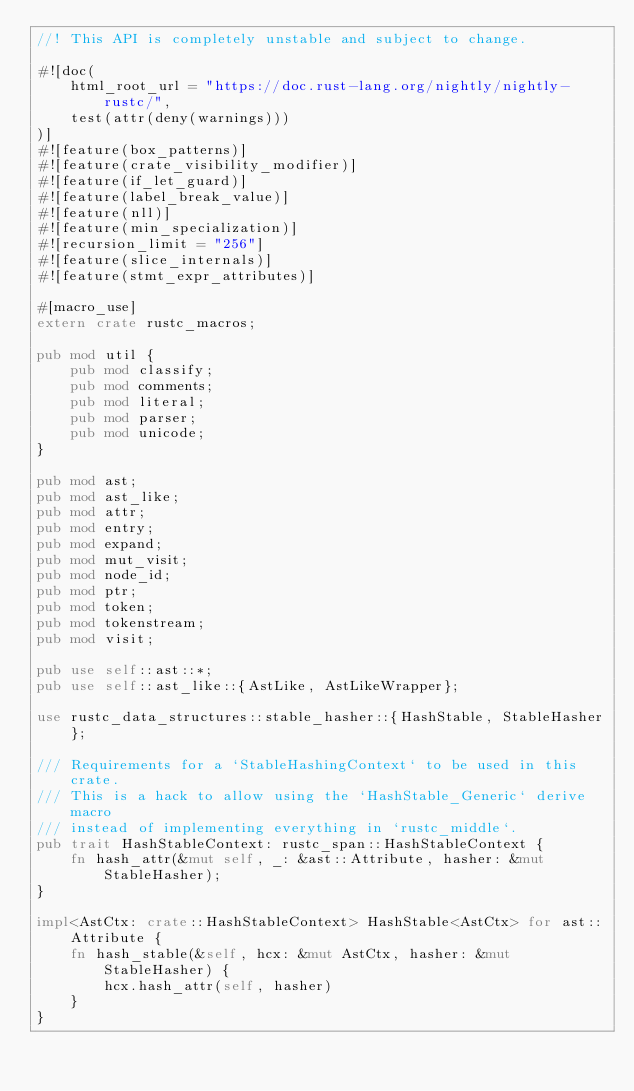<code> <loc_0><loc_0><loc_500><loc_500><_Rust_>//! This API is completely unstable and subject to change.

#![doc(
    html_root_url = "https://doc.rust-lang.org/nightly/nightly-rustc/",
    test(attr(deny(warnings)))
)]
#![feature(box_patterns)]
#![feature(crate_visibility_modifier)]
#![feature(if_let_guard)]
#![feature(label_break_value)]
#![feature(nll)]
#![feature(min_specialization)]
#![recursion_limit = "256"]
#![feature(slice_internals)]
#![feature(stmt_expr_attributes)]

#[macro_use]
extern crate rustc_macros;

pub mod util {
    pub mod classify;
    pub mod comments;
    pub mod literal;
    pub mod parser;
    pub mod unicode;
}

pub mod ast;
pub mod ast_like;
pub mod attr;
pub mod entry;
pub mod expand;
pub mod mut_visit;
pub mod node_id;
pub mod ptr;
pub mod token;
pub mod tokenstream;
pub mod visit;

pub use self::ast::*;
pub use self::ast_like::{AstLike, AstLikeWrapper};

use rustc_data_structures::stable_hasher::{HashStable, StableHasher};

/// Requirements for a `StableHashingContext` to be used in this crate.
/// This is a hack to allow using the `HashStable_Generic` derive macro
/// instead of implementing everything in `rustc_middle`.
pub trait HashStableContext: rustc_span::HashStableContext {
    fn hash_attr(&mut self, _: &ast::Attribute, hasher: &mut StableHasher);
}

impl<AstCtx: crate::HashStableContext> HashStable<AstCtx> for ast::Attribute {
    fn hash_stable(&self, hcx: &mut AstCtx, hasher: &mut StableHasher) {
        hcx.hash_attr(self, hasher)
    }
}
</code> 